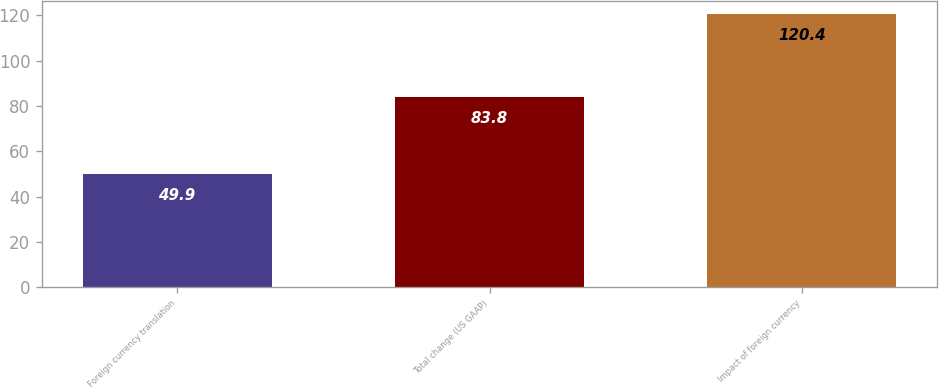Convert chart. <chart><loc_0><loc_0><loc_500><loc_500><bar_chart><fcel>Foreign currency translation<fcel>Total change (US GAAP)<fcel>Impact of foreign currency<nl><fcel>49.9<fcel>83.8<fcel>120.4<nl></chart> 